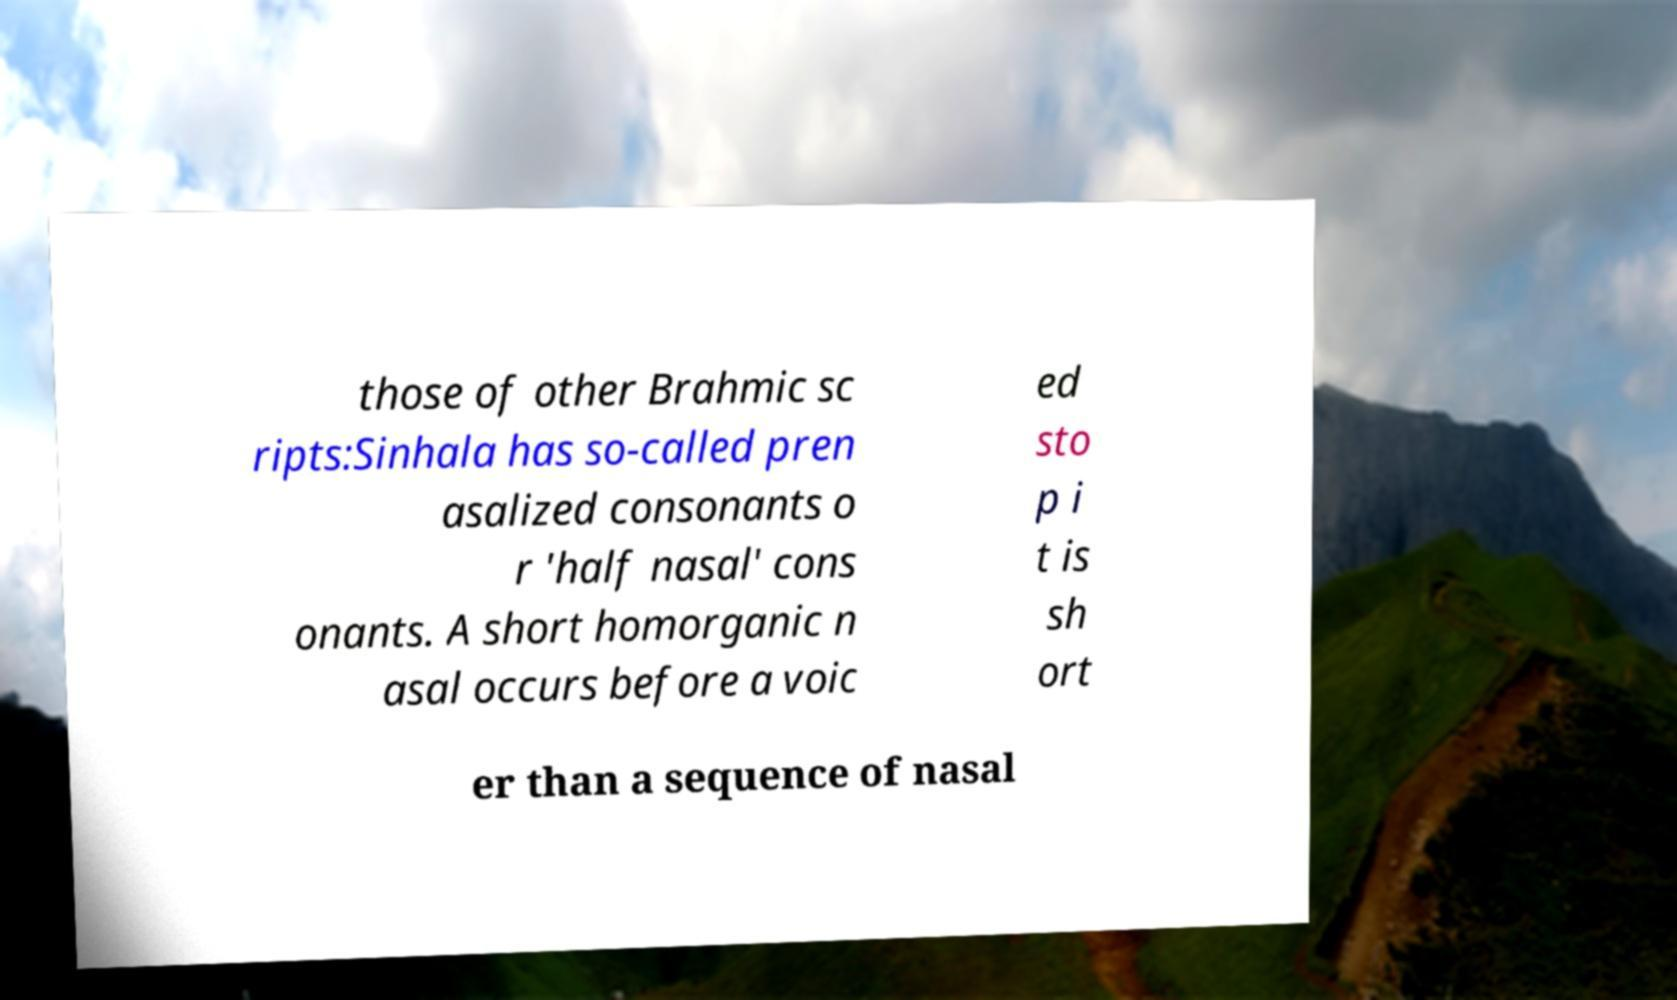Can you read and provide the text displayed in the image?This photo seems to have some interesting text. Can you extract and type it out for me? those of other Brahmic sc ripts:Sinhala has so-called pren asalized consonants o r 'half nasal' cons onants. A short homorganic n asal occurs before a voic ed sto p i t is sh ort er than a sequence of nasal 